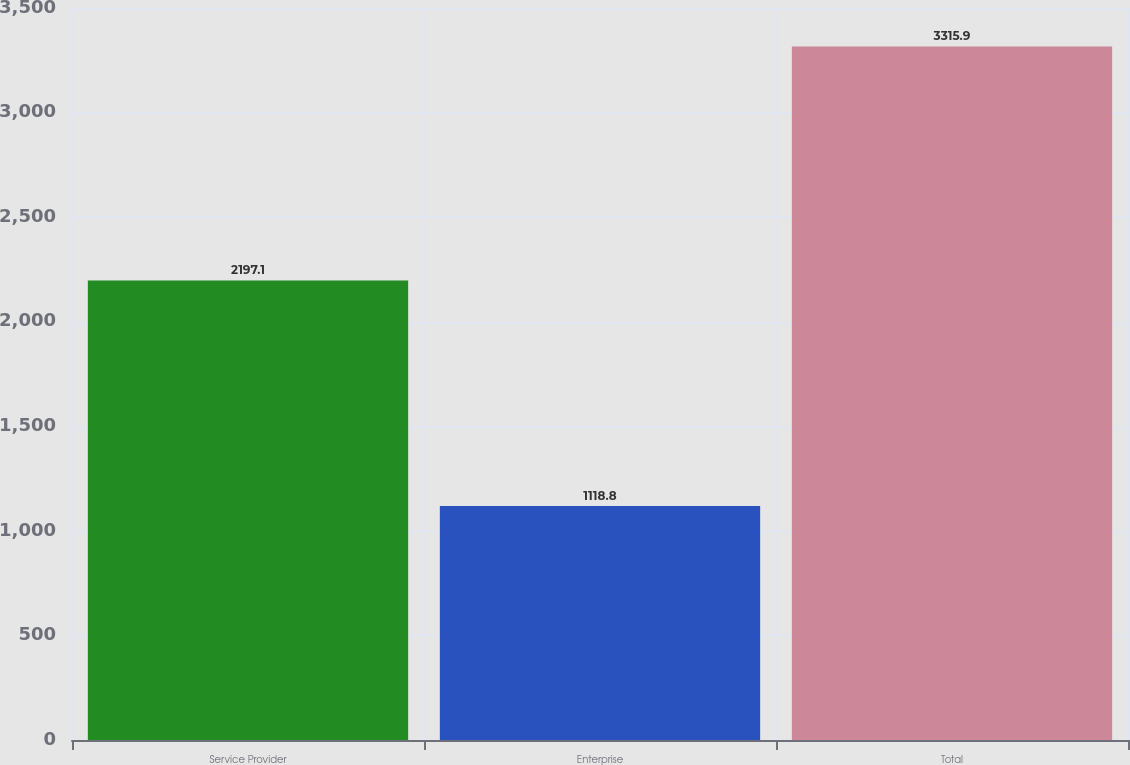Convert chart to OTSL. <chart><loc_0><loc_0><loc_500><loc_500><bar_chart><fcel>Service Provider<fcel>Enterprise<fcel>Total<nl><fcel>2197.1<fcel>1118.8<fcel>3315.9<nl></chart> 